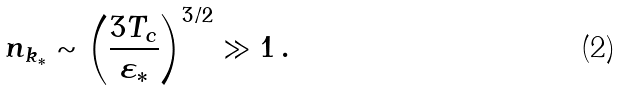Convert formula to latex. <formula><loc_0><loc_0><loc_500><loc_500>n _ { k _ { * } } \sim \left ( \frac { 3 T _ { c } } { \varepsilon _ { * } } \right ) ^ { 3 / 2 } \gg 1 \, .</formula> 